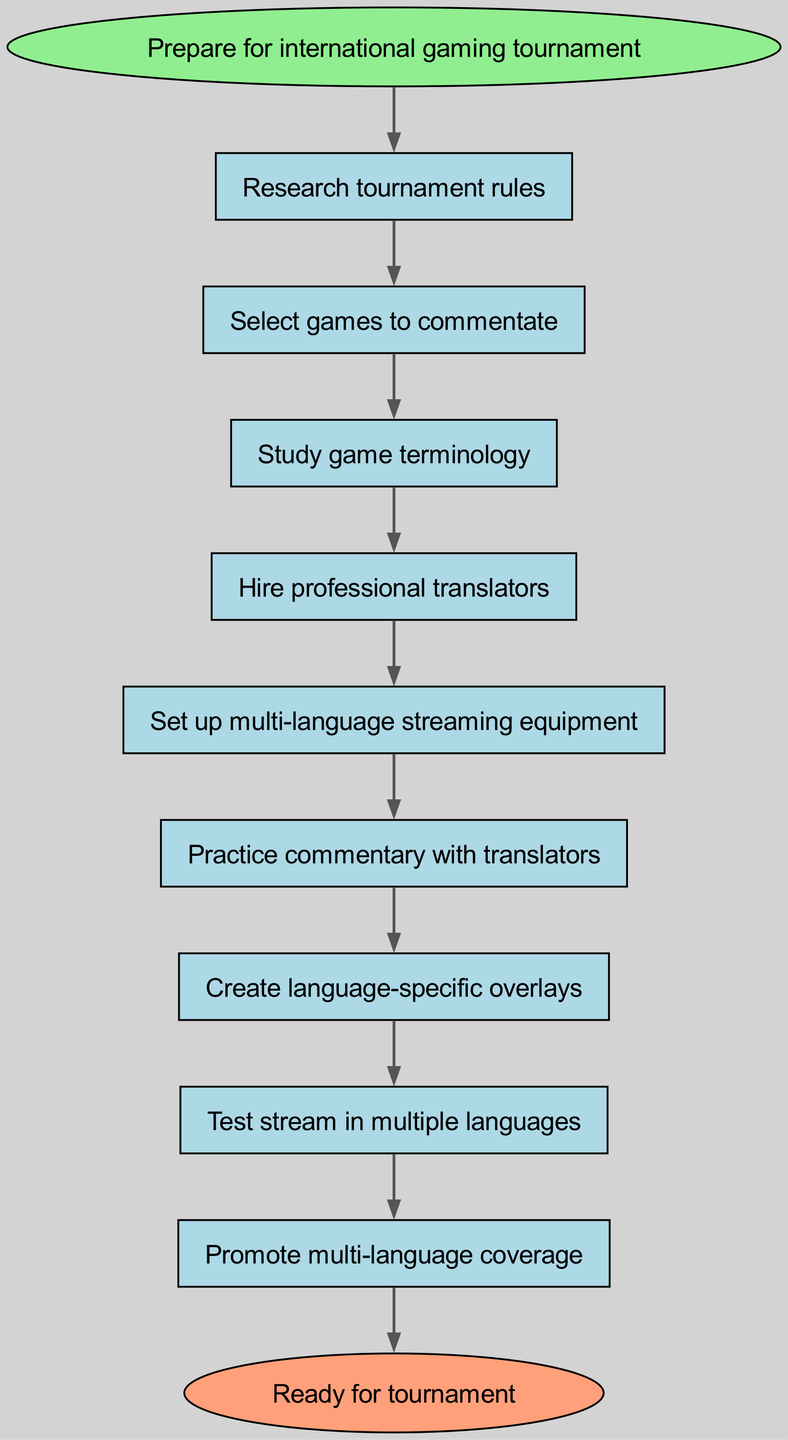What is the first step in the preparation process? The diagram indicates that the first step is labeled as "Prepare for international gaming tournament". Therefore, this is the starting point of the flow.
Answer: Prepare for international gaming tournament How many steps are there in total? By counting each individual step listed in the "steps" section of the diagram, there are a total of 9 steps leading to the final outcome.
Answer: 9 What is the last step before reaching the tournament? The final step before the end node is "Promote multi-language coverage", as it directly precedes the end of the process.
Answer: Promote multi-language coverage Which step follows "Study game terminology"? According to the flow of the diagram, the step that comes after "Study game terminology" is "Hire professional translators".
Answer: Hire professional translators How many edges are there in this flow chart? Each step connects to the next one through an edge. Since there are 9 steps, and one starting node, that results in 9 individual edges connecting them sequentially, plus one edge toward the end, yielding a total of 10 edges.
Answer: 10 What step comes before setting up equipment? The step that directly precedes "Set up multi-language streaming equipment" is "Hire professional translators", as indicated by the connecting edge between them.
Answer: Hire professional translators What is the relationship between "Create language-specific overlays" and "Test stream in multiple languages"? "Create language-specific overlays" leads directly to "Test stream in multiple languages", indicating that upon completing the overlay creation, the next action is to test the streaming process.
Answer: Directly leads to What step must be completed before practicing commentary? Before proceeding to "Practice commentary with translators", the step of "Set up multi-language streaming equipment" must be completed first, as shown in the flow sequence.
Answer: Set up multi-language streaming equipment Which step requires the involvement of professional translators? The step explicitly requiring professional translators is "Hire professional translators", highlighting its significance in the preparation process.
Answer: Hire professional translators 